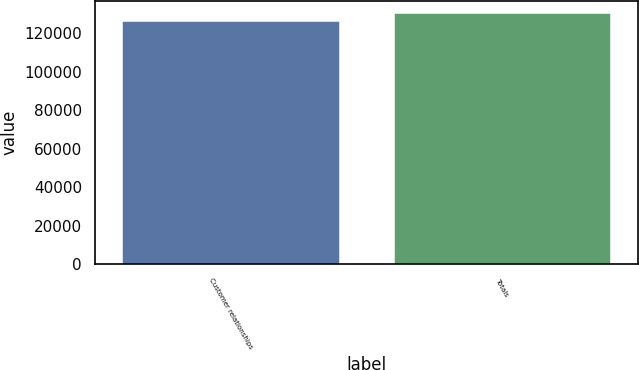Convert chart. <chart><loc_0><loc_0><loc_500><loc_500><bar_chart><fcel>Customer relationships<fcel>Totals<nl><fcel>126245<fcel>130244<nl></chart> 